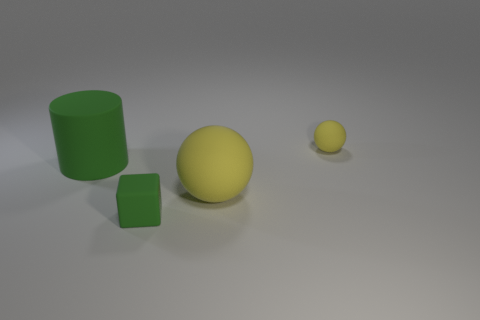What color is the tiny block right of the large green object behind the tiny rubber block?
Make the answer very short. Green. Does the tiny sphere have the same color as the big matte ball?
Ensure brevity in your answer.  Yes. Is there a rubber cylinder that is to the right of the large rubber thing left of the green thing in front of the large cylinder?
Ensure brevity in your answer.  No. What number of other things are there of the same color as the large rubber sphere?
Your response must be concise. 1. What number of matte objects are behind the big green matte object and in front of the green cylinder?
Provide a succinct answer. 0. What is the shape of the tiny yellow rubber object?
Your answer should be very brief. Sphere. How many other things are the same material as the cylinder?
Offer a very short reply. 3. What color is the small thing that is on the right side of the small matte object that is in front of the matte sphere that is to the left of the small yellow thing?
Your answer should be very brief. Yellow. There is a object that is the same size as the matte cube; what is its material?
Offer a very short reply. Rubber. How many things are green matte cubes that are to the right of the green cylinder or brown metallic spheres?
Your answer should be very brief. 1. 